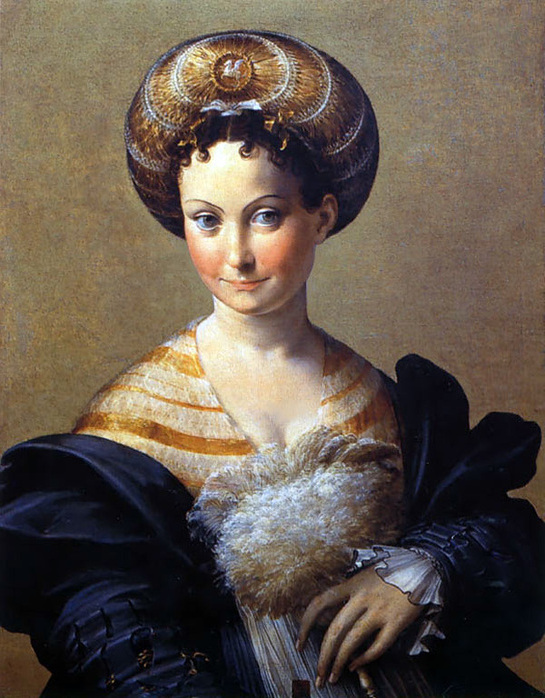What does the expression on the woman's face tell us about her? The woman's expression, marked by a gentle smile and direct engagement with the viewer through her gaze, conveys a sense of confidence and serenity. It suggests that she is comfortable in her high social standing and secure in her identity. Such expressions were often used in Renaissance portraiture to communicate the personal qualities and demeanor of the subject. 